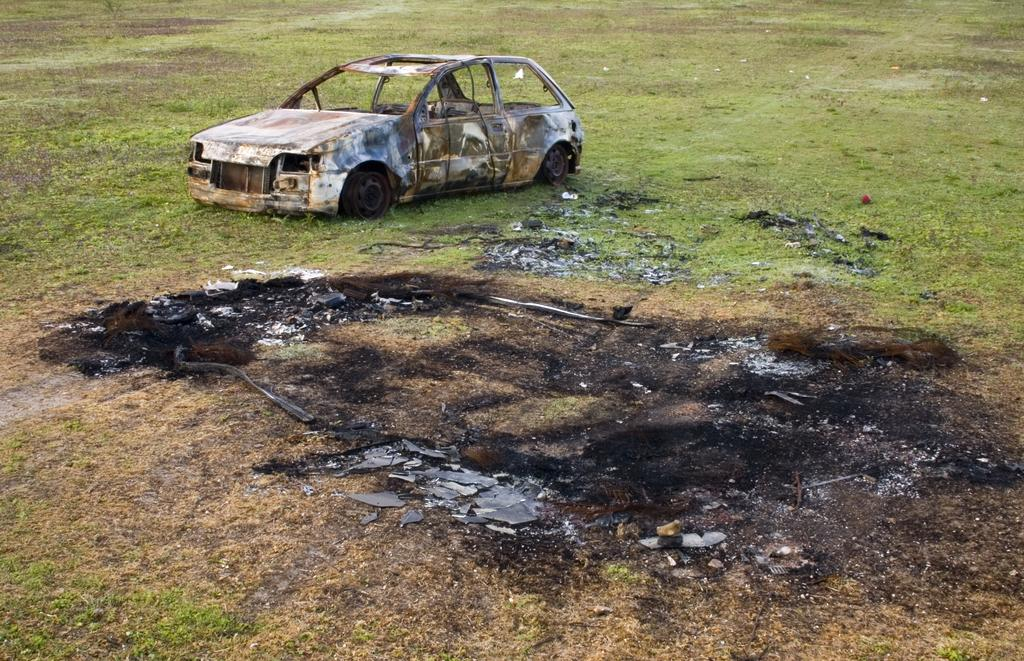What is the main subject of the image? The main subject of the image is a burnt car. What type of vegetation can be seen at the bottom of the image? There is grass visible at the bottom of the image. What type of bun is being distributed by the father in the image? There is no father or bun present in the image; it features a burnt car and grass. 